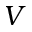<formula> <loc_0><loc_0><loc_500><loc_500>V</formula> 